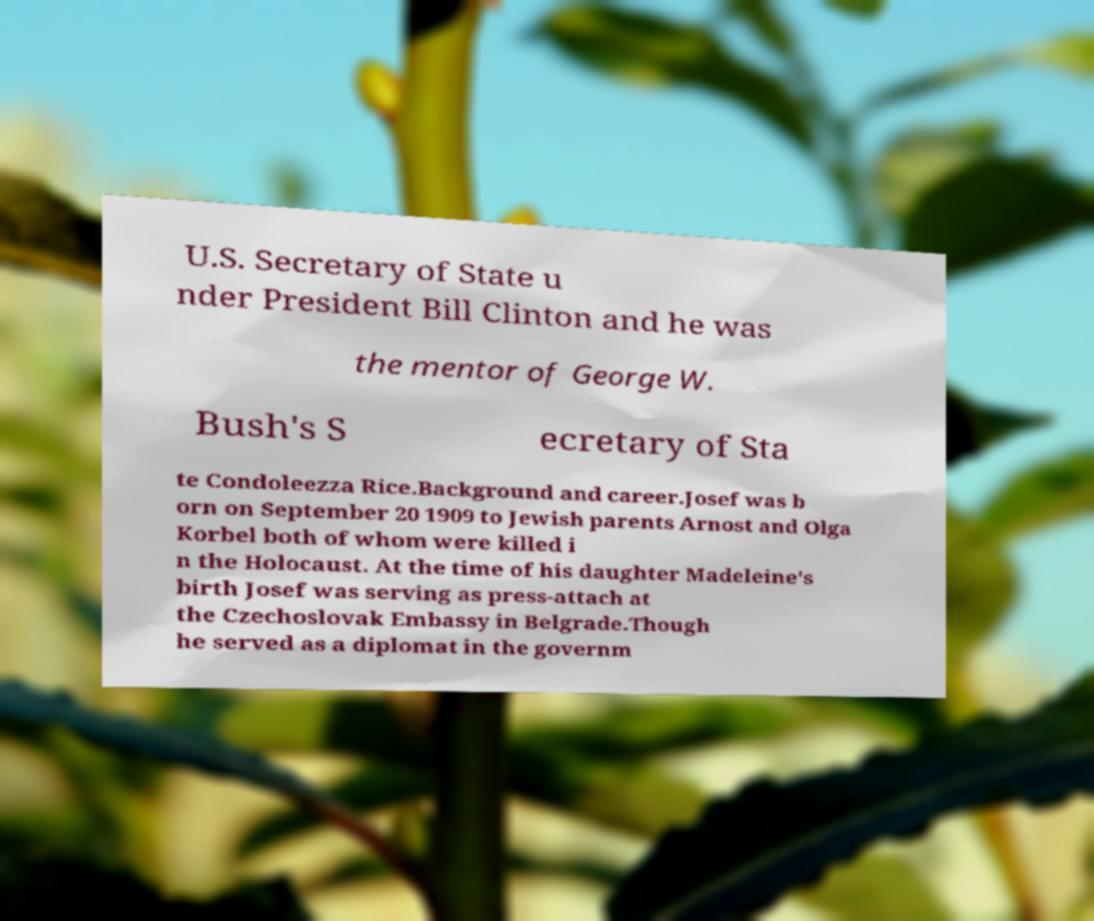Please read and relay the text visible in this image. What does it say? U.S. Secretary of State u nder President Bill Clinton and he was the mentor of George W. Bush's S ecretary of Sta te Condoleezza Rice.Background and career.Josef was b orn on September 20 1909 to Jewish parents Arnost and Olga Korbel both of whom were killed i n the Holocaust. At the time of his daughter Madeleine's birth Josef was serving as press-attach at the Czechoslovak Embassy in Belgrade.Though he served as a diplomat in the governm 